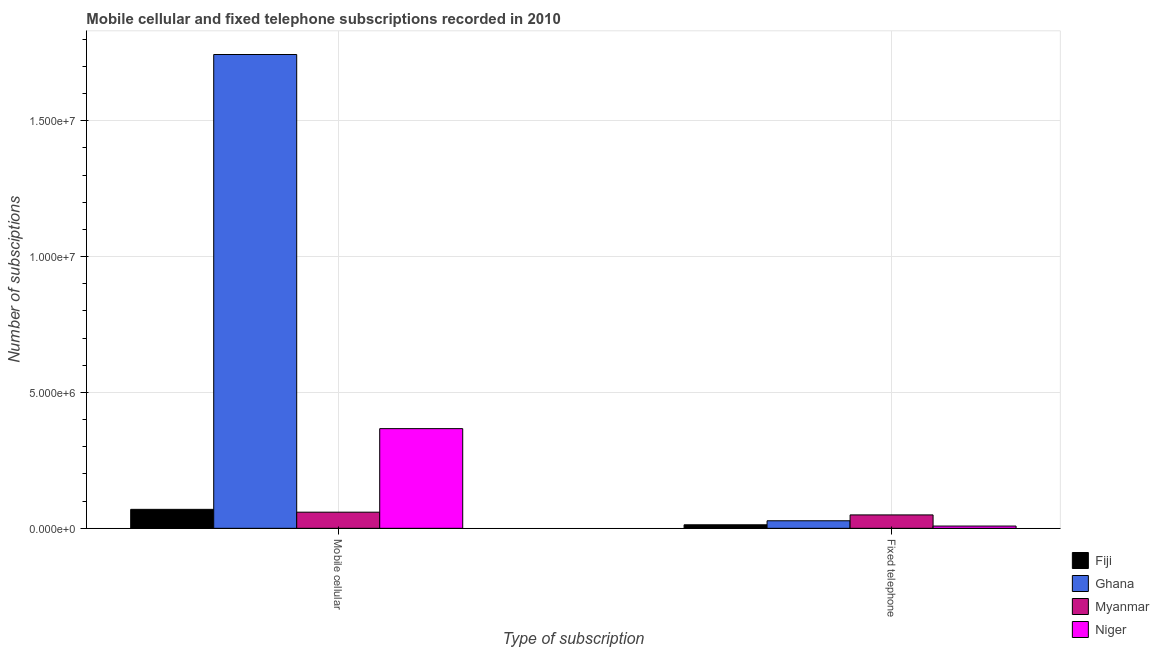How many different coloured bars are there?
Make the answer very short. 4. How many groups of bars are there?
Give a very brief answer. 2. Are the number of bars per tick equal to the number of legend labels?
Provide a short and direct response. Yes. How many bars are there on the 2nd tick from the right?
Your answer should be very brief. 4. What is the label of the 2nd group of bars from the left?
Offer a very short reply. Fixed telephone. What is the number of mobile cellular subscriptions in Ghana?
Ensure brevity in your answer.  1.74e+07. Across all countries, what is the maximum number of fixed telephone subscriptions?
Provide a short and direct response. 4.93e+05. Across all countries, what is the minimum number of mobile cellular subscriptions?
Provide a short and direct response. 5.94e+05. In which country was the number of mobile cellular subscriptions maximum?
Make the answer very short. Ghana. In which country was the number of mobile cellular subscriptions minimum?
Ensure brevity in your answer.  Myanmar. What is the total number of fixed telephone subscriptions in the graph?
Offer a terse response. 9.84e+05. What is the difference between the number of fixed telephone subscriptions in Myanmar and that in Ghana?
Give a very brief answer. 2.15e+05. What is the difference between the number of fixed telephone subscriptions in Myanmar and the number of mobile cellular subscriptions in Ghana?
Offer a very short reply. -1.69e+07. What is the average number of mobile cellular subscriptions per country?
Your answer should be very brief. 5.60e+06. What is the difference between the number of fixed telephone subscriptions and number of mobile cellular subscriptions in Niger?
Give a very brief answer. -3.59e+06. In how many countries, is the number of mobile cellular subscriptions greater than 11000000 ?
Give a very brief answer. 1. What is the ratio of the number of mobile cellular subscriptions in Fiji to that in Myanmar?
Provide a short and direct response. 1.17. Is the number of fixed telephone subscriptions in Niger less than that in Ghana?
Your response must be concise. Yes. In how many countries, is the number of fixed telephone subscriptions greater than the average number of fixed telephone subscriptions taken over all countries?
Your answer should be compact. 2. What does the 2nd bar from the left in Fixed telephone represents?
Provide a succinct answer. Ghana. What does the 2nd bar from the right in Fixed telephone represents?
Ensure brevity in your answer.  Myanmar. How many bars are there?
Offer a very short reply. 8. Are all the bars in the graph horizontal?
Provide a short and direct response. No. What is the difference between two consecutive major ticks on the Y-axis?
Your response must be concise. 5.00e+06. Does the graph contain any zero values?
Make the answer very short. No. How many legend labels are there?
Provide a succinct answer. 4. How are the legend labels stacked?
Offer a terse response. Vertical. What is the title of the graph?
Ensure brevity in your answer.  Mobile cellular and fixed telephone subscriptions recorded in 2010. Does "Seychelles" appear as one of the legend labels in the graph?
Your answer should be compact. No. What is the label or title of the X-axis?
Offer a terse response. Type of subscription. What is the label or title of the Y-axis?
Your answer should be very brief. Number of subsciptions. What is the Number of subsciptions in Fiji in Mobile cellular?
Provide a short and direct response. 6.98e+05. What is the Number of subsciptions of Ghana in Mobile cellular?
Offer a terse response. 1.74e+07. What is the Number of subsciptions in Myanmar in Mobile cellular?
Provide a succinct answer. 5.94e+05. What is the Number of subsciptions of Niger in Mobile cellular?
Provide a succinct answer. 3.67e+06. What is the Number of subsciptions of Fiji in Fixed telephone?
Provide a succinct answer. 1.30e+05. What is the Number of subsciptions in Ghana in Fixed telephone?
Offer a terse response. 2.78e+05. What is the Number of subsciptions in Myanmar in Fixed telephone?
Make the answer very short. 4.93e+05. What is the Number of subsciptions of Niger in Fixed telephone?
Keep it short and to the point. 8.34e+04. Across all Type of subscription, what is the maximum Number of subsciptions in Fiji?
Ensure brevity in your answer.  6.98e+05. Across all Type of subscription, what is the maximum Number of subsciptions in Ghana?
Make the answer very short. 1.74e+07. Across all Type of subscription, what is the maximum Number of subsciptions of Myanmar?
Ensure brevity in your answer.  5.94e+05. Across all Type of subscription, what is the maximum Number of subsciptions of Niger?
Give a very brief answer. 3.67e+06. Across all Type of subscription, what is the minimum Number of subsciptions of Fiji?
Provide a succinct answer. 1.30e+05. Across all Type of subscription, what is the minimum Number of subsciptions of Ghana?
Your answer should be very brief. 2.78e+05. Across all Type of subscription, what is the minimum Number of subsciptions of Myanmar?
Give a very brief answer. 4.93e+05. Across all Type of subscription, what is the minimum Number of subsciptions of Niger?
Offer a terse response. 8.34e+04. What is the total Number of subsciptions in Fiji in the graph?
Provide a succinct answer. 8.28e+05. What is the total Number of subsciptions in Ghana in the graph?
Offer a very short reply. 1.77e+07. What is the total Number of subsciptions in Myanmar in the graph?
Make the answer very short. 1.09e+06. What is the total Number of subsciptions in Niger in the graph?
Keep it short and to the point. 3.75e+06. What is the difference between the Number of subsciptions in Fiji in Mobile cellular and that in Fixed telephone?
Make the answer very short. 5.68e+05. What is the difference between the Number of subsciptions of Ghana in Mobile cellular and that in Fixed telephone?
Keep it short and to the point. 1.72e+07. What is the difference between the Number of subsciptions in Myanmar in Mobile cellular and that in Fixed telephone?
Your response must be concise. 1.01e+05. What is the difference between the Number of subsciptions in Niger in Mobile cellular and that in Fixed telephone?
Offer a terse response. 3.59e+06. What is the difference between the Number of subsciptions of Fiji in Mobile cellular and the Number of subsciptions of Ghana in Fixed telephone?
Make the answer very short. 4.20e+05. What is the difference between the Number of subsciptions of Fiji in Mobile cellular and the Number of subsciptions of Myanmar in Fixed telephone?
Provide a short and direct response. 2.05e+05. What is the difference between the Number of subsciptions in Fiji in Mobile cellular and the Number of subsciptions in Niger in Fixed telephone?
Give a very brief answer. 6.15e+05. What is the difference between the Number of subsciptions of Ghana in Mobile cellular and the Number of subsciptions of Myanmar in Fixed telephone?
Ensure brevity in your answer.  1.69e+07. What is the difference between the Number of subsciptions in Ghana in Mobile cellular and the Number of subsciptions in Niger in Fixed telephone?
Offer a very short reply. 1.74e+07. What is the difference between the Number of subsciptions in Myanmar in Mobile cellular and the Number of subsciptions in Niger in Fixed telephone?
Give a very brief answer. 5.11e+05. What is the average Number of subsciptions in Fiji per Type of subscription?
Offer a very short reply. 4.14e+05. What is the average Number of subsciptions in Ghana per Type of subscription?
Provide a short and direct response. 8.86e+06. What is the average Number of subsciptions of Myanmar per Type of subscription?
Give a very brief answer. 5.44e+05. What is the average Number of subsciptions of Niger per Type of subscription?
Give a very brief answer. 1.88e+06. What is the difference between the Number of subsciptions of Fiji and Number of subsciptions of Ghana in Mobile cellular?
Your answer should be compact. -1.67e+07. What is the difference between the Number of subsciptions in Fiji and Number of subsciptions in Myanmar in Mobile cellular?
Your response must be concise. 1.04e+05. What is the difference between the Number of subsciptions of Fiji and Number of subsciptions of Niger in Mobile cellular?
Your answer should be very brief. -2.97e+06. What is the difference between the Number of subsciptions of Ghana and Number of subsciptions of Myanmar in Mobile cellular?
Provide a succinct answer. 1.68e+07. What is the difference between the Number of subsciptions of Ghana and Number of subsciptions of Niger in Mobile cellular?
Provide a succinct answer. 1.38e+07. What is the difference between the Number of subsciptions of Myanmar and Number of subsciptions of Niger in Mobile cellular?
Your answer should be compact. -3.07e+06. What is the difference between the Number of subsciptions of Fiji and Number of subsciptions of Ghana in Fixed telephone?
Make the answer very short. -1.48e+05. What is the difference between the Number of subsciptions of Fiji and Number of subsciptions of Myanmar in Fixed telephone?
Keep it short and to the point. -3.63e+05. What is the difference between the Number of subsciptions in Fiji and Number of subsciptions in Niger in Fixed telephone?
Offer a very short reply. 4.65e+04. What is the difference between the Number of subsciptions in Ghana and Number of subsciptions in Myanmar in Fixed telephone?
Offer a very short reply. -2.15e+05. What is the difference between the Number of subsciptions in Ghana and Number of subsciptions in Niger in Fixed telephone?
Provide a succinct answer. 1.95e+05. What is the difference between the Number of subsciptions in Myanmar and Number of subsciptions in Niger in Fixed telephone?
Give a very brief answer. 4.10e+05. What is the ratio of the Number of subsciptions in Fiji in Mobile cellular to that in Fixed telephone?
Offer a very short reply. 5.38. What is the ratio of the Number of subsciptions in Ghana in Mobile cellular to that in Fixed telephone?
Provide a succinct answer. 62.75. What is the ratio of the Number of subsciptions of Myanmar in Mobile cellular to that in Fixed telephone?
Give a very brief answer. 1.2. What is the ratio of the Number of subsciptions in Niger in Mobile cellular to that in Fixed telephone?
Your answer should be compact. 44. What is the difference between the highest and the second highest Number of subsciptions in Fiji?
Ensure brevity in your answer.  5.68e+05. What is the difference between the highest and the second highest Number of subsciptions in Ghana?
Your response must be concise. 1.72e+07. What is the difference between the highest and the second highest Number of subsciptions of Myanmar?
Keep it short and to the point. 1.01e+05. What is the difference between the highest and the second highest Number of subsciptions of Niger?
Your response must be concise. 3.59e+06. What is the difference between the highest and the lowest Number of subsciptions in Fiji?
Your answer should be very brief. 5.68e+05. What is the difference between the highest and the lowest Number of subsciptions in Ghana?
Give a very brief answer. 1.72e+07. What is the difference between the highest and the lowest Number of subsciptions in Myanmar?
Offer a terse response. 1.01e+05. What is the difference between the highest and the lowest Number of subsciptions of Niger?
Provide a short and direct response. 3.59e+06. 